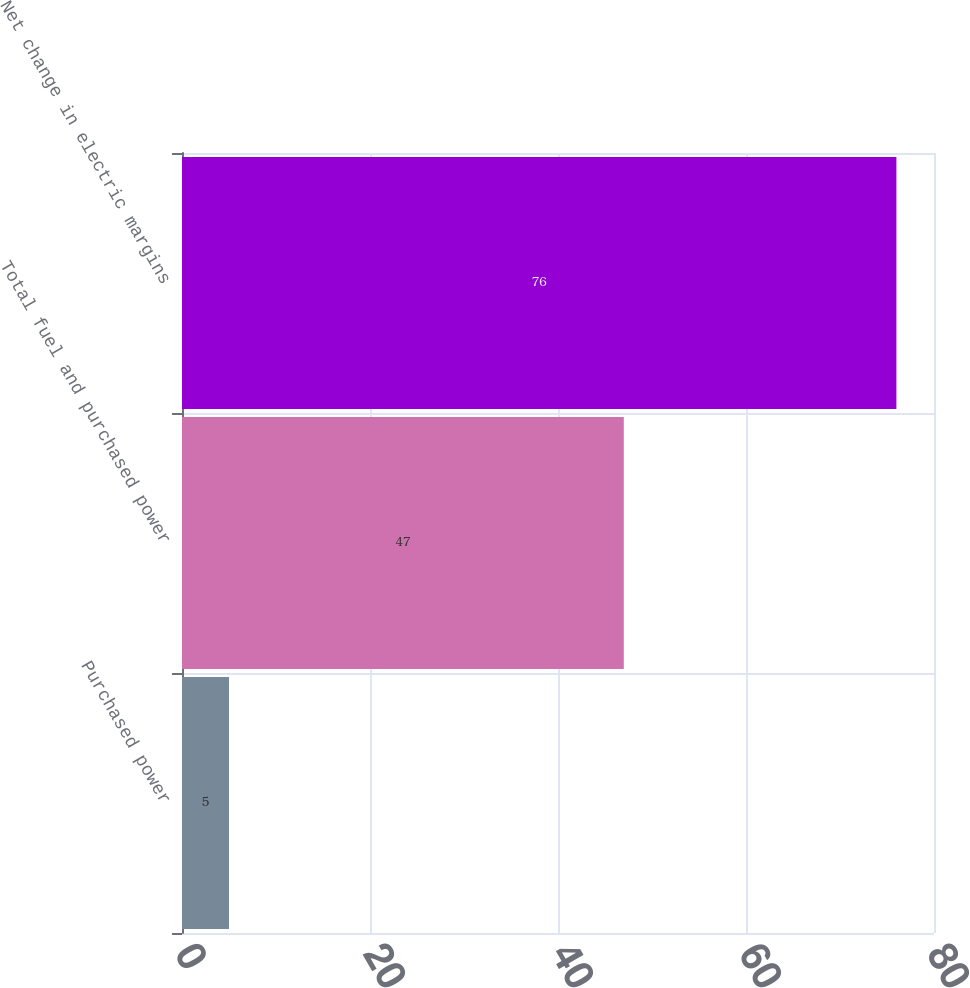Convert chart to OTSL. <chart><loc_0><loc_0><loc_500><loc_500><bar_chart><fcel>Purchased power<fcel>Total fuel and purchased power<fcel>Net change in electric margins<nl><fcel>5<fcel>47<fcel>76<nl></chart> 